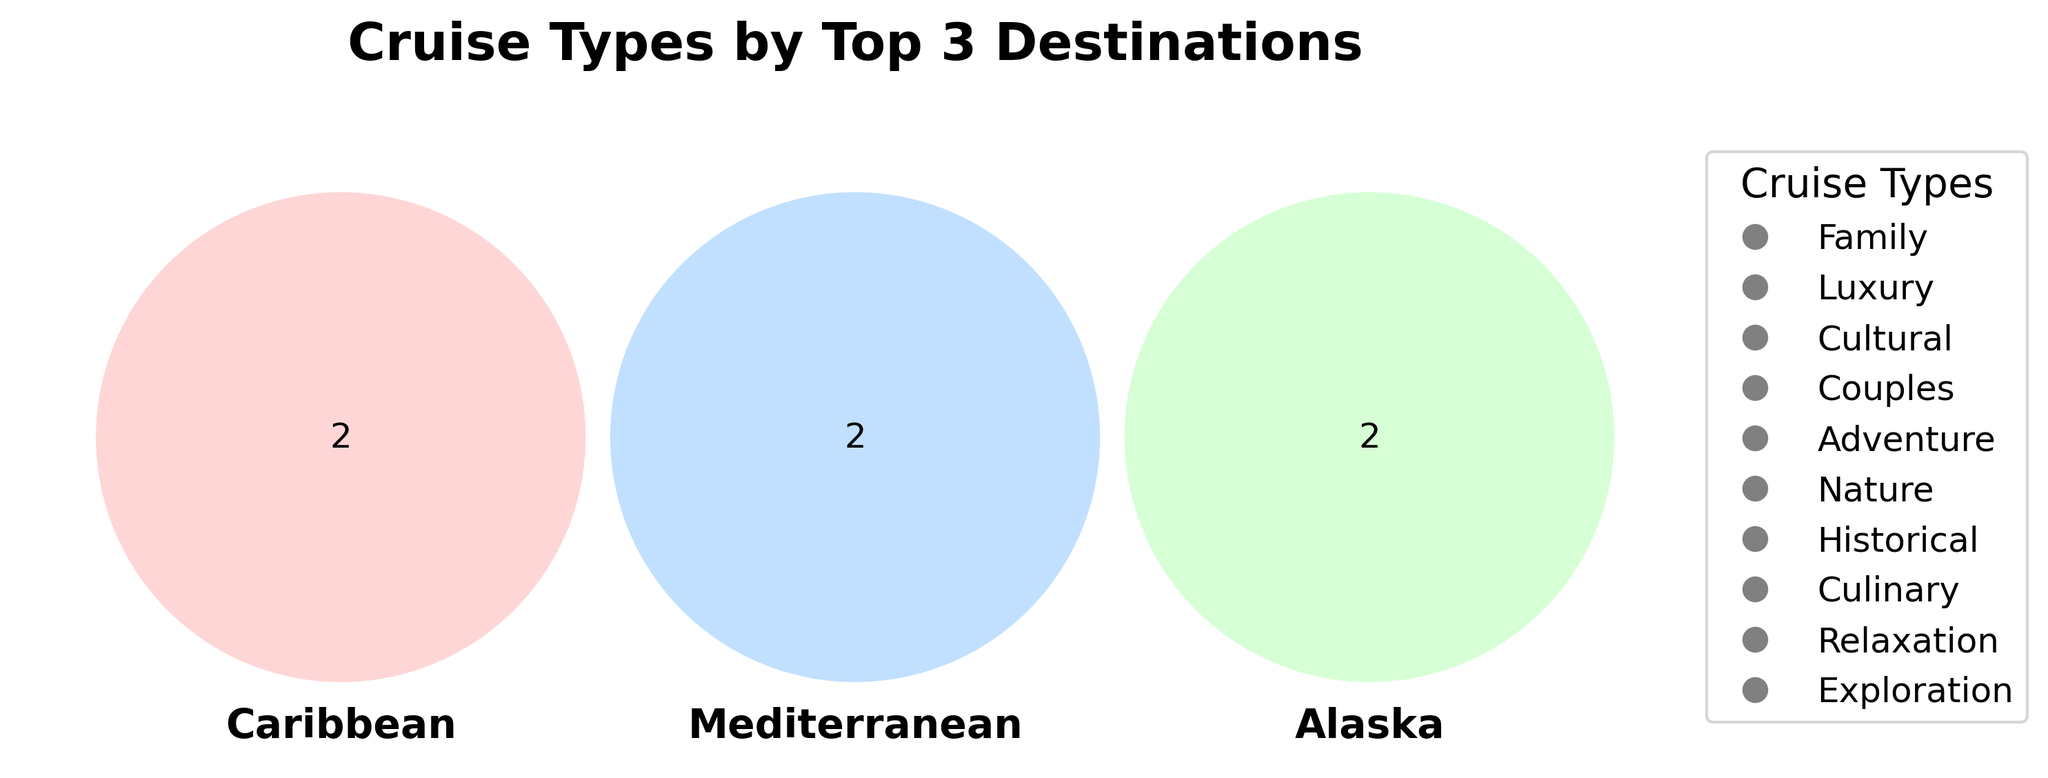What is the title of the Venn Diagram? The Venn diagram title can be found at the top of the figure.
Answer: Cruise Types by Top 3 Destinations Which destinations are represented in the Venn Diagram? Examine the labels of overlapping circles to find the destinations being compared.
Answer: Caribbean, Mediterranean, Alaska How many cruise types are shared between Caribbean and Mediterranean? Look at the intersection area between Caribbean and Mediterranean in the Venn Diagram.
Answer: 0 What colors represent the sets for Caribbean, Mediterranean, and Alaska? Identify the colors assigned to each set by checking the legend and the filled portions of each circle.
Answer: Red for Caribbean, Blue for Mediterranean, Green for Alaska Which destination has the most unique cruise types that are not shared with others? Compare the non-overlapping portions of each destination's circle in the Venn Diagram.
Answer: Alaska Are there any cruise types common to all three destinations? Observe the central intersection area where all three circles overlap.
Answer: No How many cruise types does Caribbean have? Count all the sections, including overlaps, belonging to the Caribbean circle.
Answer: 2 Which cruise type is common to Caribbean and Alaska but not Mediterranean? Check the intersection area between Caribbean and Alaska that does not overlap with Mediterranean.
Answer: Adventure How many unique cruise types are there in total among the three destinations? Sum singular and overlapping cruise types across all three destinations.
Answer: 6 